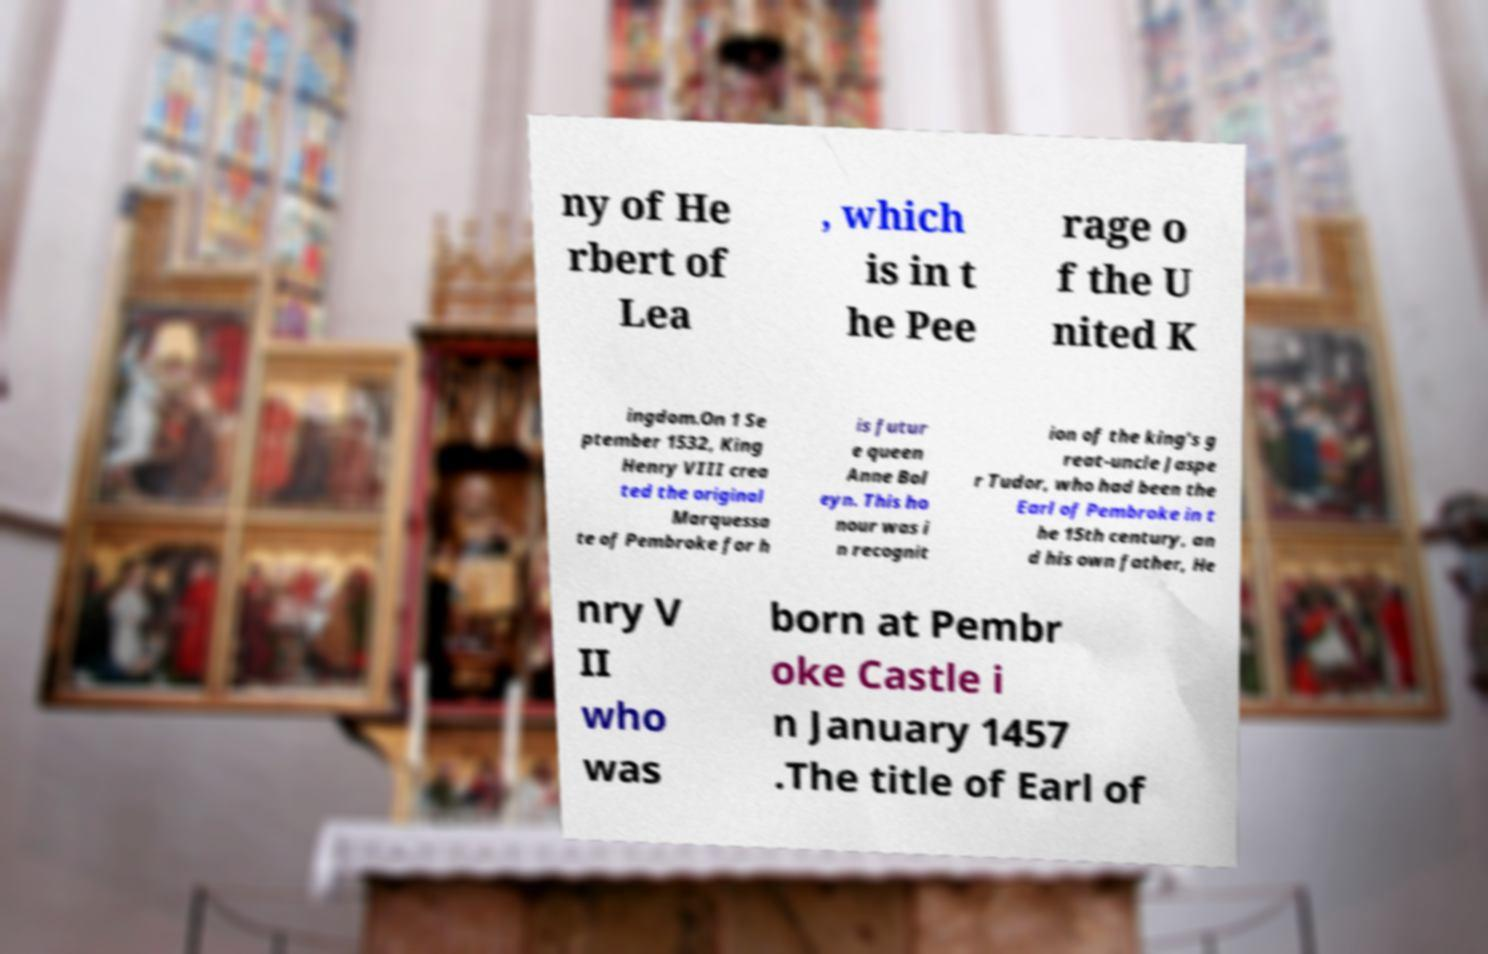What messages or text are displayed in this image? I need them in a readable, typed format. ny of He rbert of Lea , which is in t he Pee rage o f the U nited K ingdom.On 1 Se ptember 1532, King Henry VIII crea ted the original Marquessa te of Pembroke for h is futur e queen Anne Bol eyn. This ho nour was i n recognit ion of the king's g reat-uncle Jaspe r Tudor, who had been the Earl of Pembroke in t he 15th century, an d his own father, He nry V II who was born at Pembr oke Castle i n January 1457 .The title of Earl of 